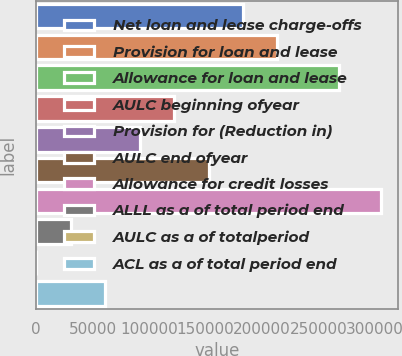Convert chart. <chart><loc_0><loc_0><loc_500><loc_500><bar_chart><fcel>Net loan and lease charge-offs<fcel>Provision for loan and lease<fcel>Allowance for loan and lease<fcel>AULC beginning ofyear<fcel>Provision for (Reduction in)<fcel>AULC end ofyear<fcel>Allowance for credit losses<fcel>ALLL as a of total period end<fcel>AULC as a of totalperiod<fcel>ACL as a of total period end<nl><fcel>183182<fcel>213713<fcel>268347<fcel>122122<fcel>91591.3<fcel>152652<fcel>305304<fcel>30530.5<fcel>0.15<fcel>61060.9<nl></chart> 